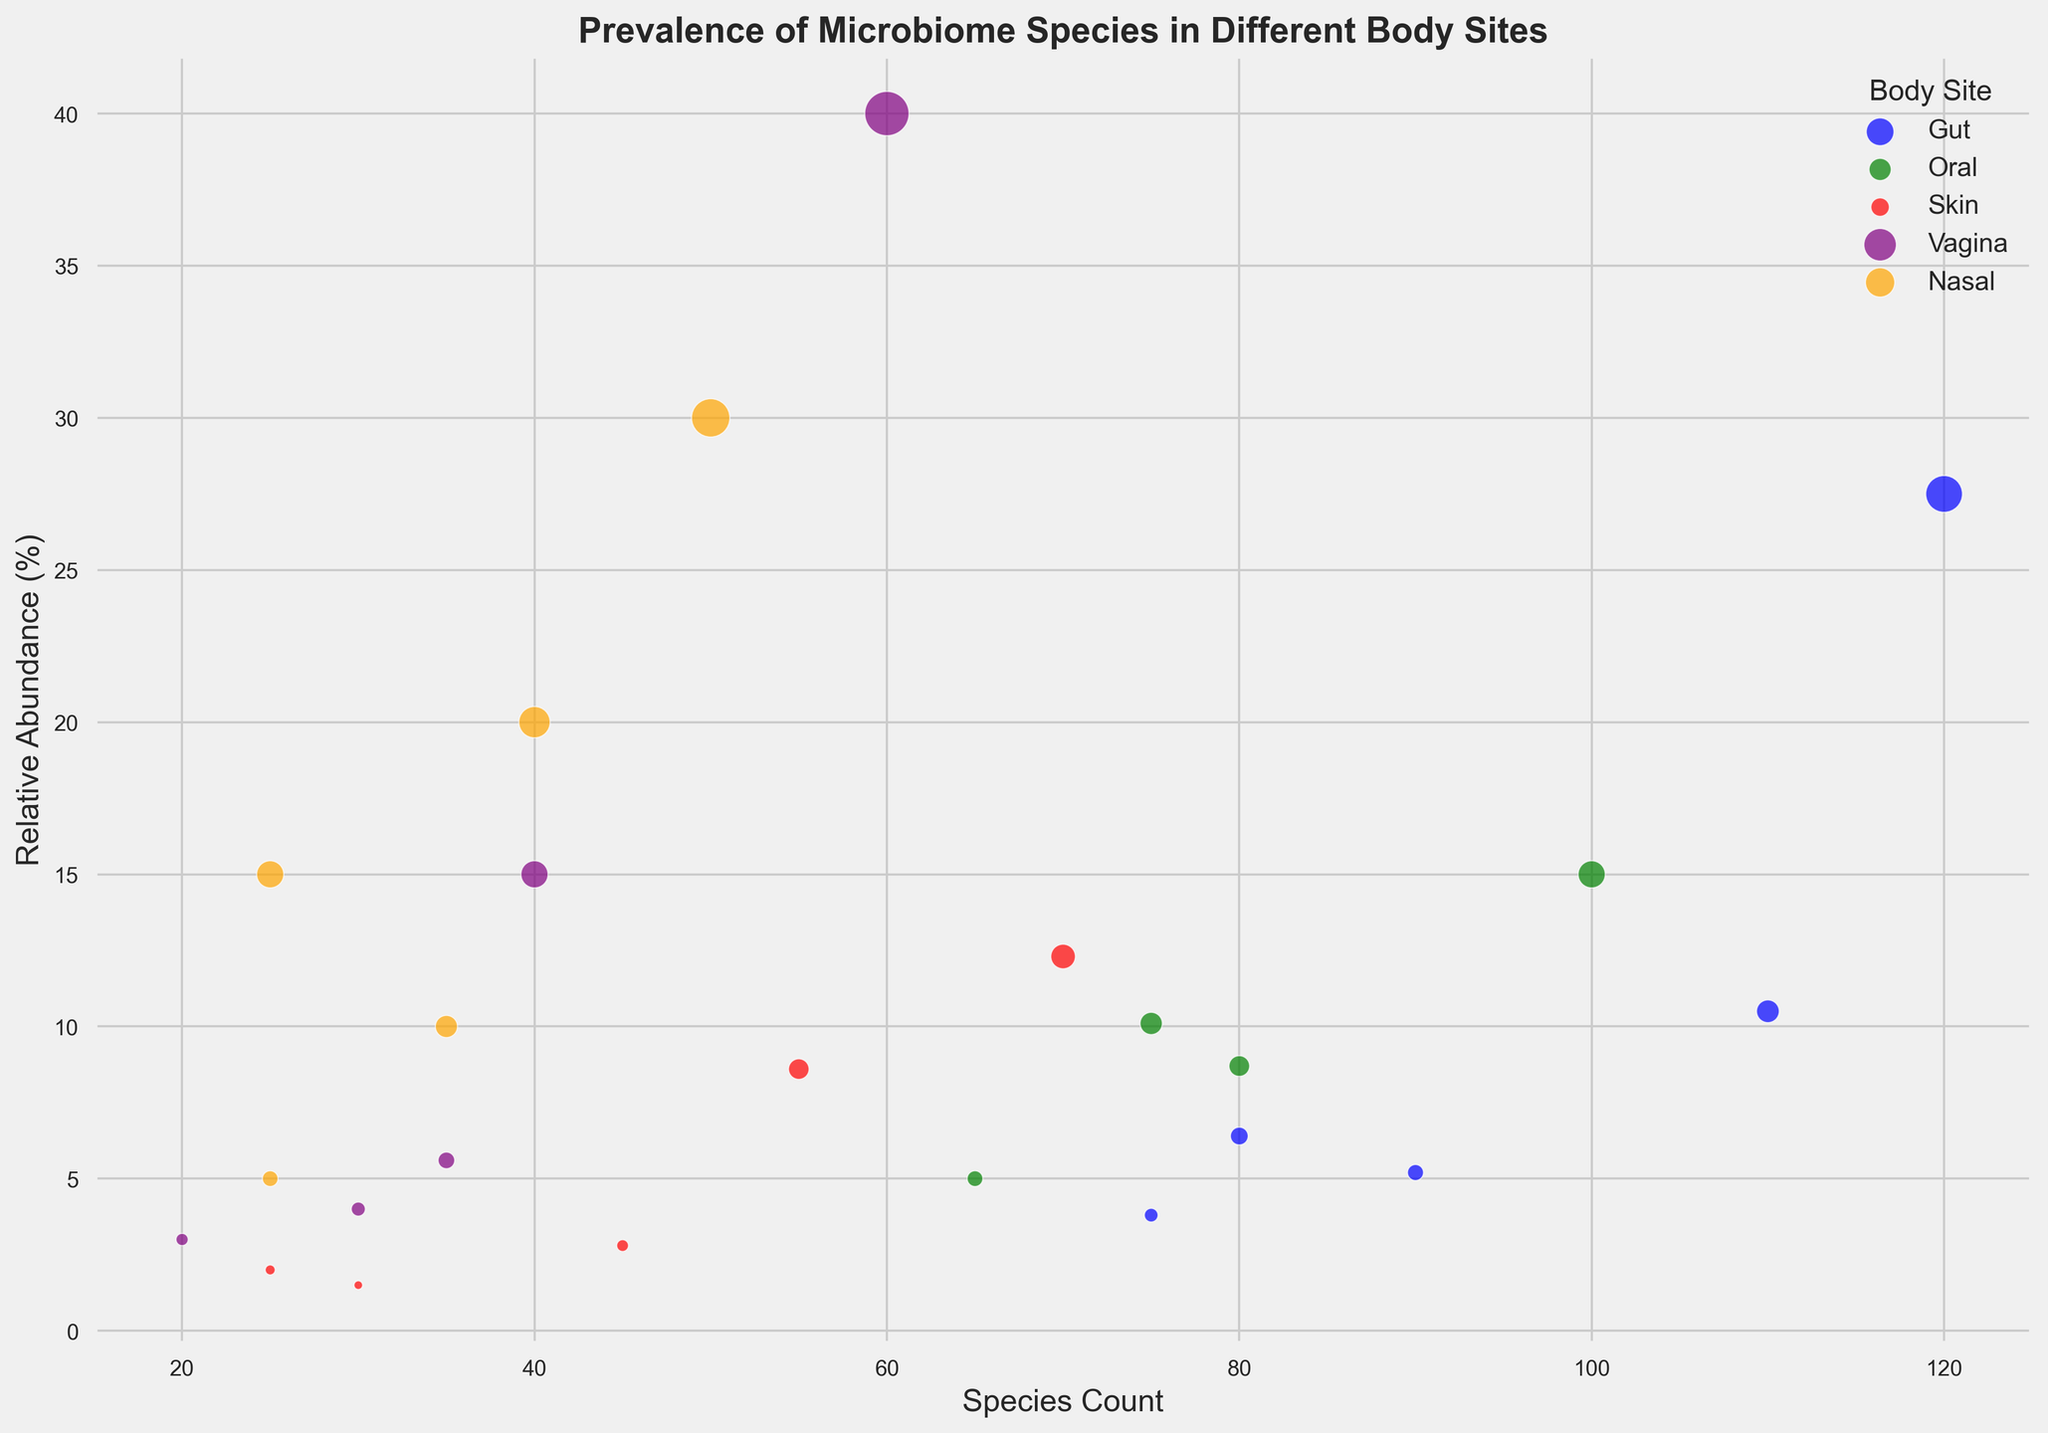Which microbiome species has the highest relative abundance in the Vagina? Looking at the purple bubbles representing the Vagina, we see that "Lactobacillus" has the largest bubble, corresponding to the highest relative abundance.
Answer: Lactobacillus Compare the species counts of Staphylococcus in the Skin and Nasal body sites. Which has a higher count? The red bubble representing "Staphylococcus" in the Skin has a species count of 70, while the orange bubble for "Staphylococcus" in the Nasal site has a species count of 40. Thus, the Skin has a higher count.
Answer: Skin What's the difference in relative abundance between Corynebacterium in the Skin and Nasal sites? The red bubble for "Corynebacterium" in the Skin has a relative abundance of 2.8%. The orange bubble for "Corynebacterium" in the Nasal site has a relative abundance of 30%. The difference is 30% - 2.8% = 27.2%.
Answer: 27.2% Which body site has the species with the lowest relative abundance and what is that species? Looking at all the bubbles, the smallest one corresponds to "Micrococcus" in the Skin, with a relative abundance of 1.5%.
Answer: Skin, Micrococcus Compare the relative abundances of Streptococcus in the Oral and Nasal sites. Are they equal? The green bubble for "Streptococcus" in the Oral site has a relative abundance of 15.0%. The orange bubble for "Streptococcus" in the Nasal site has a relative abundance of 5.0%. They are not equal.
Answer: No What is the average relative abundance of the bacterial species in the Vagina? The relative abundances for the Vagina are 40.0%, 15.0%, 5.6%, 4.0%, and 3.0%. Adding them gives 40.0 + 15.0 + 5.6 + 4.0 + 3.0 = 67.6%. Dividing by 5 gives an average of 67.6 / 5 = 13.52%.
Answer: 13.52% Which body sites contain "Staphylococcus," and what are their relative abundances and species counts? "Staphylococcus" appears in both the Skin and Nasal sites. The red bubble for Skin has a relative abundance of 12.3% and a species count of 70, while the orange bubble for Nasal has a relative abundance of 20.0% and a species count of 40.
Answer: Skin: 12.3%, 70; Nasal: 20.0%, 40 What's the total species count for the Gut microbiome? Summing the species counts for the Gut gives: 120 + 110 + 90 + 80 + 75 = 475.
Answer: 475 